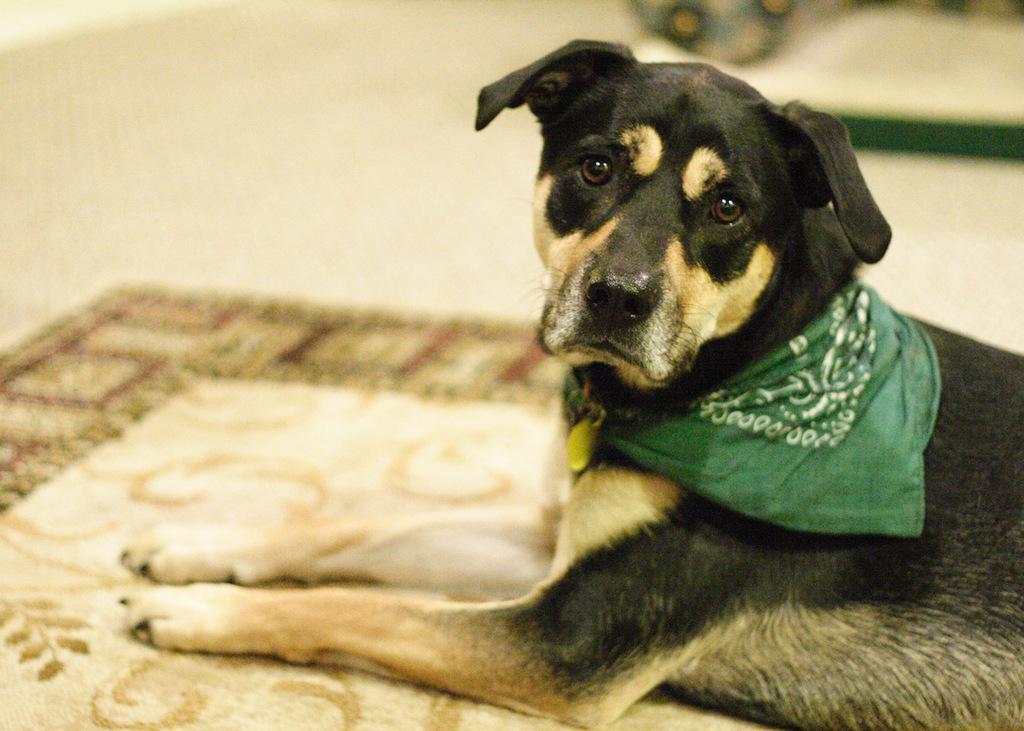Describe this image in one or two sentences. The picture is taken in a house. In the foreground of the picture there is a dog. At the bottom there is a mat. The background is blurred. 